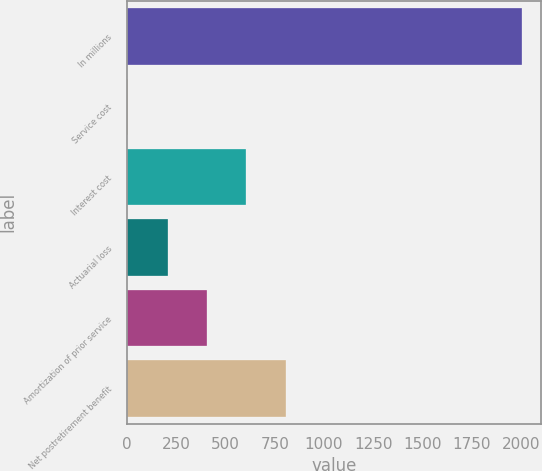Convert chart. <chart><loc_0><loc_0><loc_500><loc_500><bar_chart><fcel>In millions<fcel>Service cost<fcel>Interest cost<fcel>Actuarial loss<fcel>Amortization of prior service<fcel>Net postretirement benefit<nl><fcel>2003<fcel>7<fcel>605.8<fcel>206.6<fcel>406.2<fcel>805.4<nl></chart> 